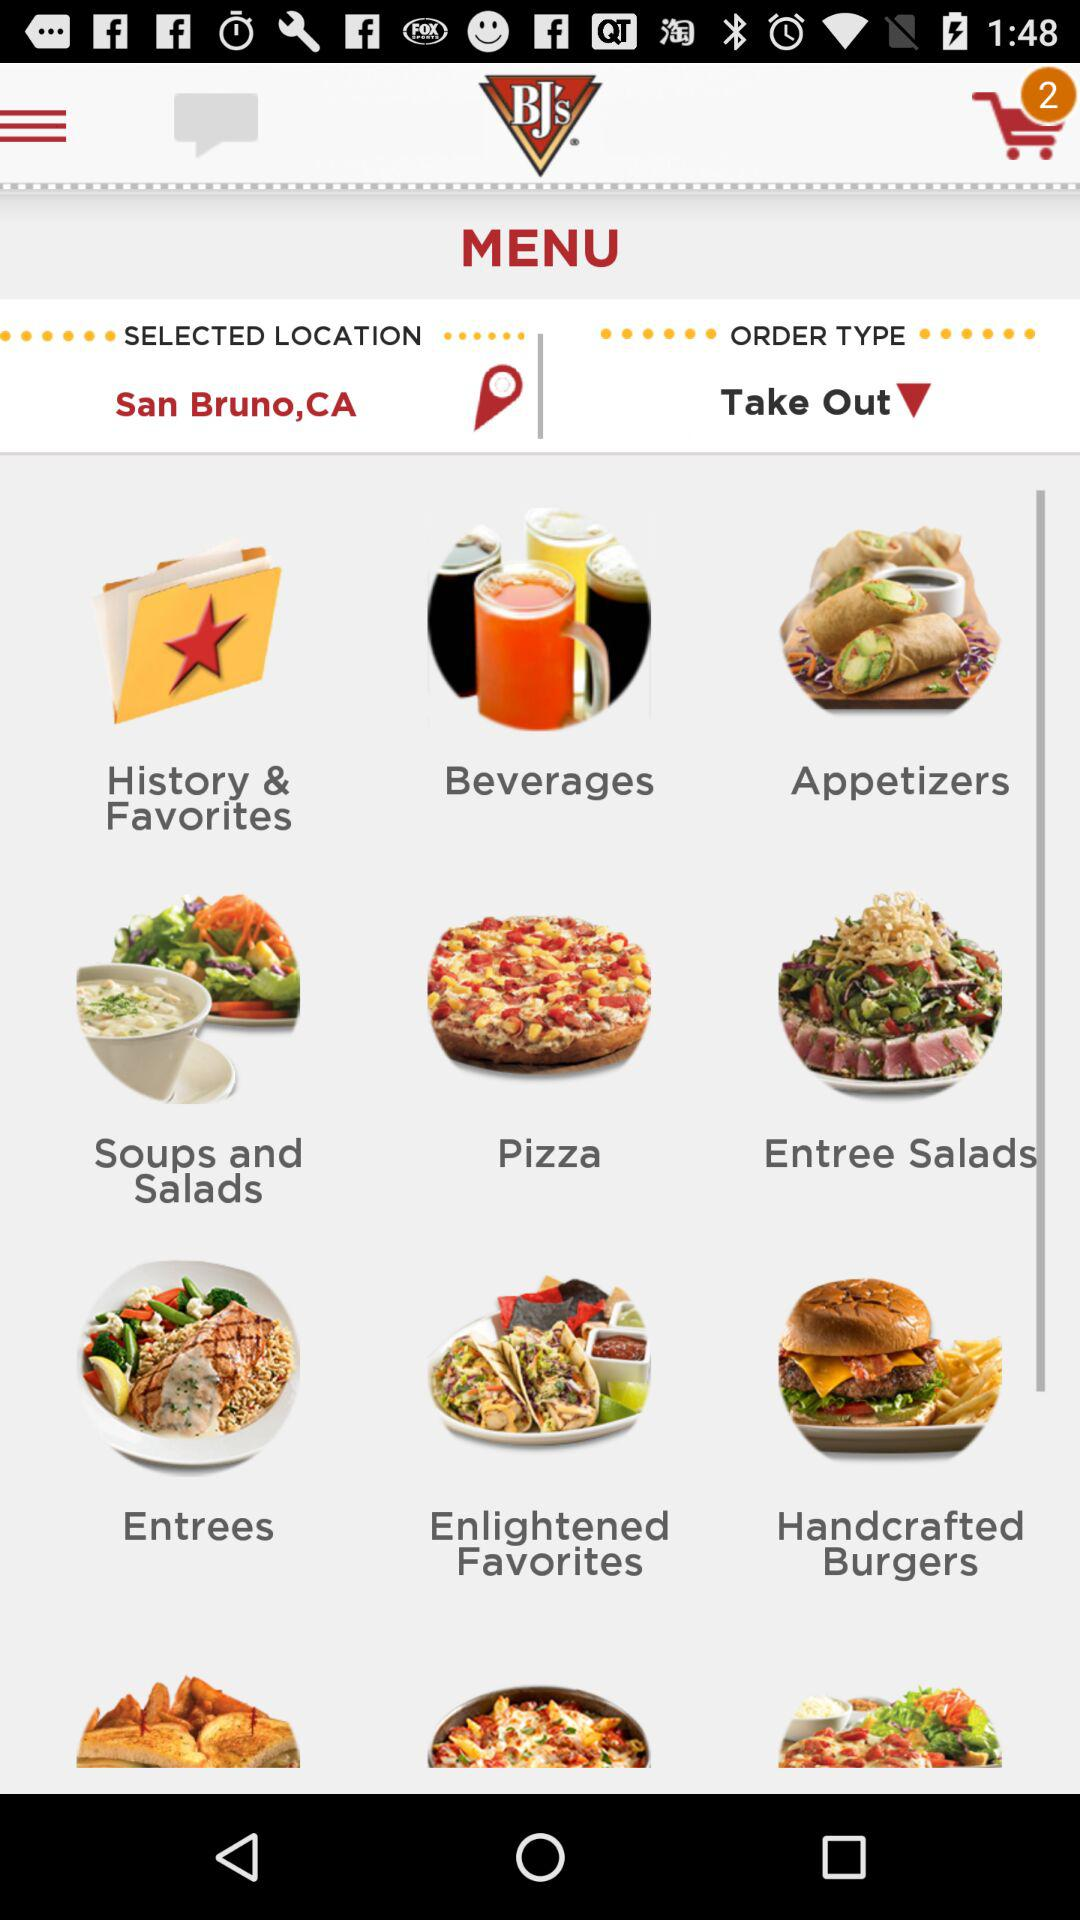What is the selected location? The selected location is San Bruno, CA. 